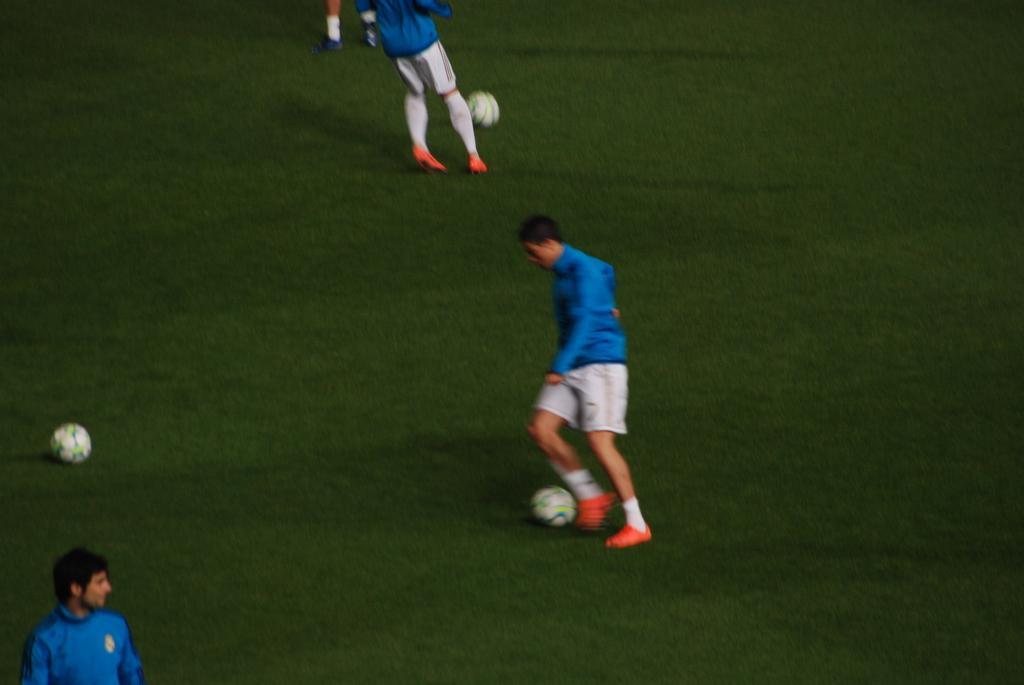How would you summarize this image in a sentence or two? In the middle a boy is playing the football. He wears a blue color shirt and white color short then also there is another football in the left and it's a green grass in the ground. 